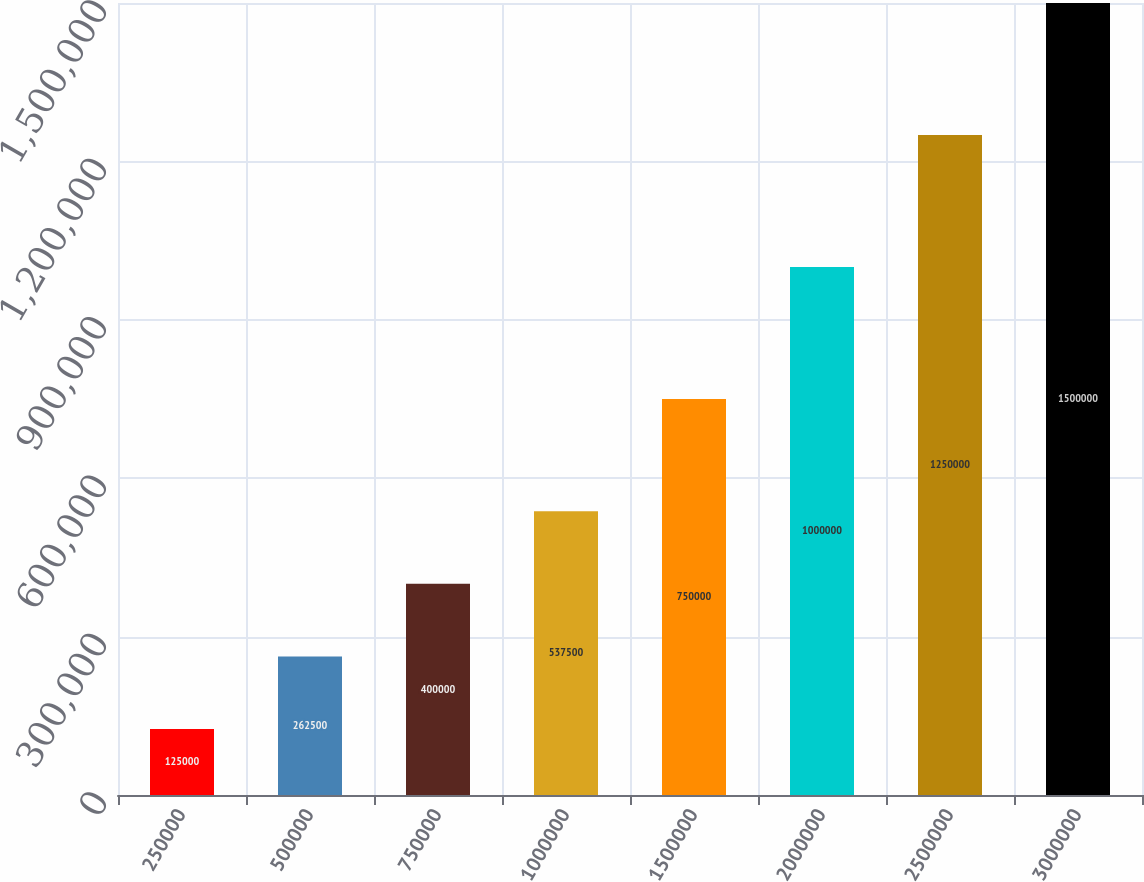Convert chart to OTSL. <chart><loc_0><loc_0><loc_500><loc_500><bar_chart><fcel>250000<fcel>500000<fcel>750000<fcel>1000000<fcel>1500000<fcel>2000000<fcel>2500000<fcel>3000000<nl><fcel>125000<fcel>262500<fcel>400000<fcel>537500<fcel>750000<fcel>1e+06<fcel>1.25e+06<fcel>1.5e+06<nl></chart> 